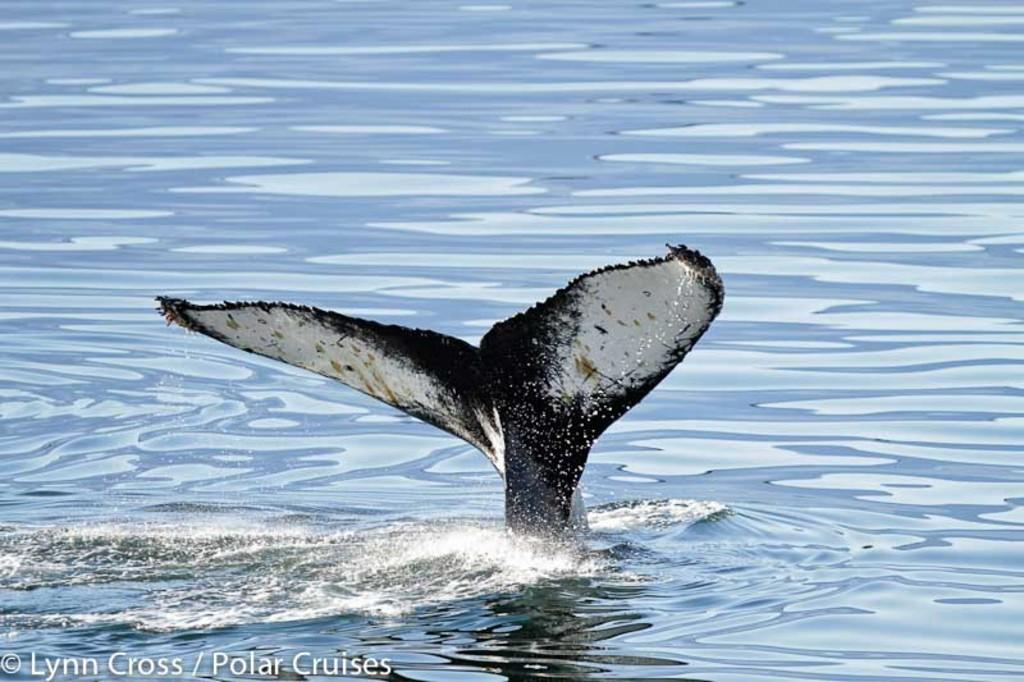What is the main subject of the image? There is a whale in the water in the image. Can you describe any additional features or elements in the image? There is a watermark in the bottom left corner of the image. What type of glue is being used to hold the paint on the cattle in the image? There are no cattle or paint present in the image; it features a whale in the water and a watermark in the corner. 